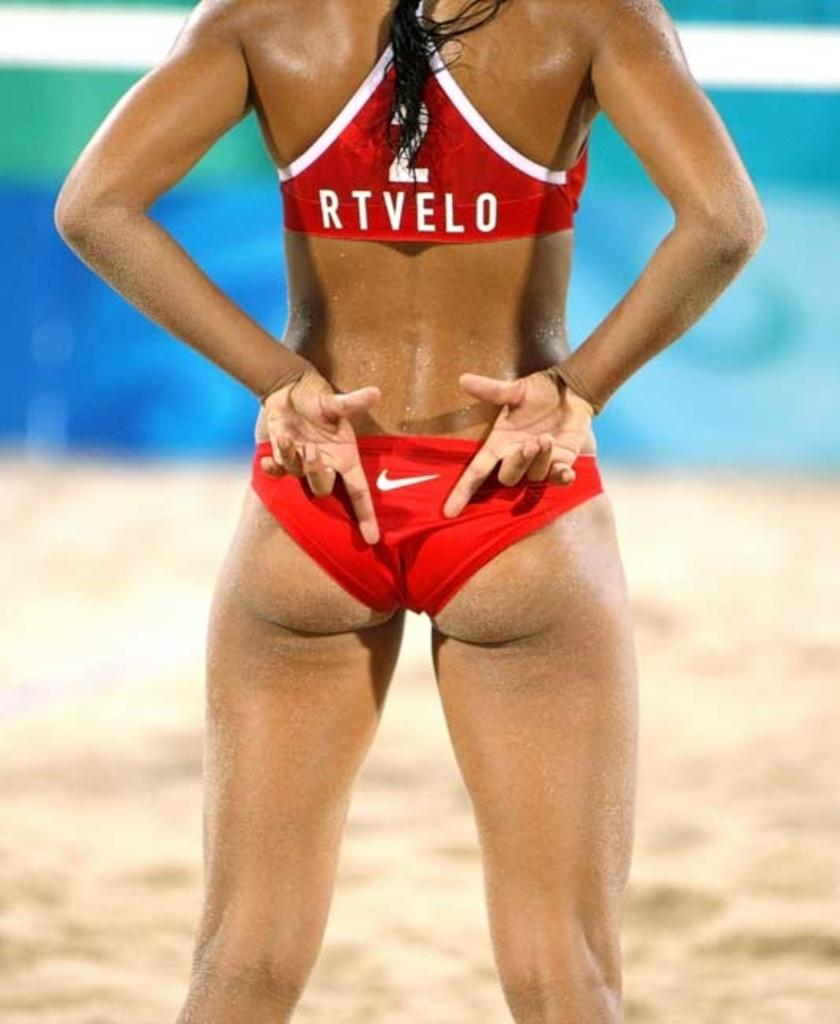Provide a one-sentence caption for the provided image. The back of a girl showing that is wearing a twp piece red and white bathing suit that has the #2 written above RTVELO on the top. 